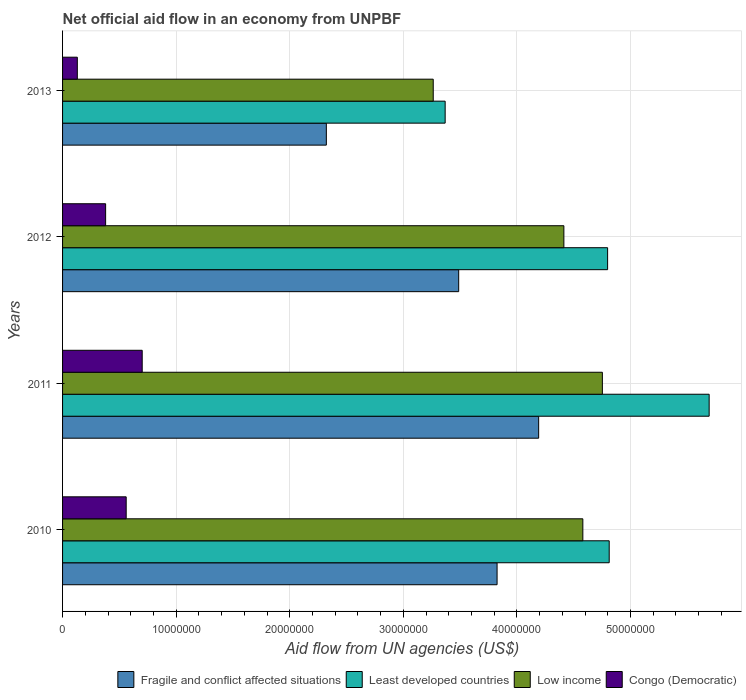How many different coloured bars are there?
Your answer should be compact. 4. How many groups of bars are there?
Give a very brief answer. 4. Are the number of bars per tick equal to the number of legend labels?
Offer a terse response. Yes. How many bars are there on the 1st tick from the top?
Make the answer very short. 4. What is the label of the 1st group of bars from the top?
Ensure brevity in your answer.  2013. In how many cases, is the number of bars for a given year not equal to the number of legend labels?
Your answer should be very brief. 0. What is the net official aid flow in Fragile and conflict affected situations in 2010?
Offer a terse response. 3.82e+07. Across all years, what is the maximum net official aid flow in Congo (Democratic)?
Give a very brief answer. 7.01e+06. Across all years, what is the minimum net official aid flow in Low income?
Give a very brief answer. 3.26e+07. In which year was the net official aid flow in Least developed countries maximum?
Keep it short and to the point. 2011. What is the total net official aid flow in Least developed countries in the graph?
Ensure brevity in your answer.  1.87e+08. What is the difference between the net official aid flow in Least developed countries in 2010 and that in 2013?
Your answer should be very brief. 1.44e+07. What is the difference between the net official aid flow in Least developed countries in 2011 and the net official aid flow in Low income in 2012?
Provide a succinct answer. 1.28e+07. What is the average net official aid flow in Low income per year?
Provide a short and direct response. 4.25e+07. In the year 2012, what is the difference between the net official aid flow in Fragile and conflict affected situations and net official aid flow in Congo (Democratic)?
Provide a succinct answer. 3.11e+07. What is the ratio of the net official aid flow in Congo (Democratic) in 2010 to that in 2013?
Your answer should be very brief. 4.31. Is the difference between the net official aid flow in Fragile and conflict affected situations in 2010 and 2011 greater than the difference between the net official aid flow in Congo (Democratic) in 2010 and 2011?
Your response must be concise. No. What is the difference between the highest and the second highest net official aid flow in Least developed countries?
Provide a succinct answer. 8.80e+06. What is the difference between the highest and the lowest net official aid flow in Least developed countries?
Offer a very short reply. 2.32e+07. In how many years, is the net official aid flow in Low income greater than the average net official aid flow in Low income taken over all years?
Your answer should be very brief. 3. Is the sum of the net official aid flow in Least developed countries in 2010 and 2011 greater than the maximum net official aid flow in Fragile and conflict affected situations across all years?
Your answer should be very brief. Yes. What does the 4th bar from the top in 2011 represents?
Provide a succinct answer. Fragile and conflict affected situations. What does the 1st bar from the bottom in 2011 represents?
Offer a terse response. Fragile and conflict affected situations. Are all the bars in the graph horizontal?
Give a very brief answer. Yes. How many years are there in the graph?
Your answer should be compact. 4. What is the difference between two consecutive major ticks on the X-axis?
Provide a succinct answer. 1.00e+07. Does the graph contain any zero values?
Ensure brevity in your answer.  No. Where does the legend appear in the graph?
Offer a very short reply. Bottom right. How many legend labels are there?
Give a very brief answer. 4. What is the title of the graph?
Offer a very short reply. Net official aid flow in an economy from UNPBF. Does "Ukraine" appear as one of the legend labels in the graph?
Ensure brevity in your answer.  No. What is the label or title of the X-axis?
Give a very brief answer. Aid flow from UN agencies (US$). What is the Aid flow from UN agencies (US$) in Fragile and conflict affected situations in 2010?
Offer a terse response. 3.82e+07. What is the Aid flow from UN agencies (US$) of Least developed countries in 2010?
Your answer should be very brief. 4.81e+07. What is the Aid flow from UN agencies (US$) in Low income in 2010?
Keep it short and to the point. 4.58e+07. What is the Aid flow from UN agencies (US$) in Congo (Democratic) in 2010?
Offer a very short reply. 5.60e+06. What is the Aid flow from UN agencies (US$) in Fragile and conflict affected situations in 2011?
Offer a terse response. 4.19e+07. What is the Aid flow from UN agencies (US$) in Least developed countries in 2011?
Ensure brevity in your answer.  5.69e+07. What is the Aid flow from UN agencies (US$) in Low income in 2011?
Provide a short and direct response. 4.75e+07. What is the Aid flow from UN agencies (US$) of Congo (Democratic) in 2011?
Offer a terse response. 7.01e+06. What is the Aid flow from UN agencies (US$) of Fragile and conflict affected situations in 2012?
Give a very brief answer. 3.49e+07. What is the Aid flow from UN agencies (US$) in Least developed countries in 2012?
Offer a terse response. 4.80e+07. What is the Aid flow from UN agencies (US$) in Low income in 2012?
Provide a short and direct response. 4.41e+07. What is the Aid flow from UN agencies (US$) of Congo (Democratic) in 2012?
Your answer should be compact. 3.79e+06. What is the Aid flow from UN agencies (US$) in Fragile and conflict affected situations in 2013?
Offer a terse response. 2.32e+07. What is the Aid flow from UN agencies (US$) of Least developed countries in 2013?
Your answer should be compact. 3.37e+07. What is the Aid flow from UN agencies (US$) of Low income in 2013?
Ensure brevity in your answer.  3.26e+07. What is the Aid flow from UN agencies (US$) in Congo (Democratic) in 2013?
Ensure brevity in your answer.  1.30e+06. Across all years, what is the maximum Aid flow from UN agencies (US$) of Fragile and conflict affected situations?
Give a very brief answer. 4.19e+07. Across all years, what is the maximum Aid flow from UN agencies (US$) in Least developed countries?
Provide a succinct answer. 5.69e+07. Across all years, what is the maximum Aid flow from UN agencies (US$) in Low income?
Keep it short and to the point. 4.75e+07. Across all years, what is the maximum Aid flow from UN agencies (US$) in Congo (Democratic)?
Offer a very short reply. 7.01e+06. Across all years, what is the minimum Aid flow from UN agencies (US$) of Fragile and conflict affected situations?
Your response must be concise. 2.32e+07. Across all years, what is the minimum Aid flow from UN agencies (US$) of Least developed countries?
Ensure brevity in your answer.  3.37e+07. Across all years, what is the minimum Aid flow from UN agencies (US$) in Low income?
Make the answer very short. 3.26e+07. Across all years, what is the minimum Aid flow from UN agencies (US$) in Congo (Democratic)?
Keep it short and to the point. 1.30e+06. What is the total Aid flow from UN agencies (US$) in Fragile and conflict affected situations in the graph?
Provide a short and direct response. 1.38e+08. What is the total Aid flow from UN agencies (US$) in Least developed countries in the graph?
Your answer should be very brief. 1.87e+08. What is the total Aid flow from UN agencies (US$) in Low income in the graph?
Your response must be concise. 1.70e+08. What is the total Aid flow from UN agencies (US$) in Congo (Democratic) in the graph?
Make the answer very short. 1.77e+07. What is the difference between the Aid flow from UN agencies (US$) in Fragile and conflict affected situations in 2010 and that in 2011?
Ensure brevity in your answer.  -3.66e+06. What is the difference between the Aid flow from UN agencies (US$) in Least developed countries in 2010 and that in 2011?
Offer a very short reply. -8.80e+06. What is the difference between the Aid flow from UN agencies (US$) in Low income in 2010 and that in 2011?
Provide a succinct answer. -1.72e+06. What is the difference between the Aid flow from UN agencies (US$) in Congo (Democratic) in 2010 and that in 2011?
Provide a succinct answer. -1.41e+06. What is the difference between the Aid flow from UN agencies (US$) of Fragile and conflict affected situations in 2010 and that in 2012?
Keep it short and to the point. 3.38e+06. What is the difference between the Aid flow from UN agencies (US$) of Low income in 2010 and that in 2012?
Your answer should be compact. 1.67e+06. What is the difference between the Aid flow from UN agencies (US$) of Congo (Democratic) in 2010 and that in 2012?
Offer a terse response. 1.81e+06. What is the difference between the Aid flow from UN agencies (US$) of Fragile and conflict affected situations in 2010 and that in 2013?
Provide a succinct answer. 1.50e+07. What is the difference between the Aid flow from UN agencies (US$) of Least developed countries in 2010 and that in 2013?
Your answer should be very brief. 1.44e+07. What is the difference between the Aid flow from UN agencies (US$) of Low income in 2010 and that in 2013?
Your answer should be compact. 1.32e+07. What is the difference between the Aid flow from UN agencies (US$) in Congo (Democratic) in 2010 and that in 2013?
Offer a terse response. 4.30e+06. What is the difference between the Aid flow from UN agencies (US$) in Fragile and conflict affected situations in 2011 and that in 2012?
Give a very brief answer. 7.04e+06. What is the difference between the Aid flow from UN agencies (US$) in Least developed countries in 2011 and that in 2012?
Provide a succinct answer. 8.94e+06. What is the difference between the Aid flow from UN agencies (US$) in Low income in 2011 and that in 2012?
Provide a succinct answer. 3.39e+06. What is the difference between the Aid flow from UN agencies (US$) of Congo (Democratic) in 2011 and that in 2012?
Ensure brevity in your answer.  3.22e+06. What is the difference between the Aid flow from UN agencies (US$) of Fragile and conflict affected situations in 2011 and that in 2013?
Offer a very short reply. 1.87e+07. What is the difference between the Aid flow from UN agencies (US$) of Least developed countries in 2011 and that in 2013?
Offer a terse response. 2.32e+07. What is the difference between the Aid flow from UN agencies (US$) in Low income in 2011 and that in 2013?
Your answer should be compact. 1.49e+07. What is the difference between the Aid flow from UN agencies (US$) in Congo (Democratic) in 2011 and that in 2013?
Provide a succinct answer. 5.71e+06. What is the difference between the Aid flow from UN agencies (US$) of Fragile and conflict affected situations in 2012 and that in 2013?
Make the answer very short. 1.16e+07. What is the difference between the Aid flow from UN agencies (US$) in Least developed countries in 2012 and that in 2013?
Your answer should be very brief. 1.43e+07. What is the difference between the Aid flow from UN agencies (US$) of Low income in 2012 and that in 2013?
Your answer should be very brief. 1.15e+07. What is the difference between the Aid flow from UN agencies (US$) in Congo (Democratic) in 2012 and that in 2013?
Offer a very short reply. 2.49e+06. What is the difference between the Aid flow from UN agencies (US$) of Fragile and conflict affected situations in 2010 and the Aid flow from UN agencies (US$) of Least developed countries in 2011?
Offer a terse response. -1.87e+07. What is the difference between the Aid flow from UN agencies (US$) in Fragile and conflict affected situations in 2010 and the Aid flow from UN agencies (US$) in Low income in 2011?
Your answer should be very brief. -9.27e+06. What is the difference between the Aid flow from UN agencies (US$) in Fragile and conflict affected situations in 2010 and the Aid flow from UN agencies (US$) in Congo (Democratic) in 2011?
Your answer should be compact. 3.12e+07. What is the difference between the Aid flow from UN agencies (US$) of Least developed countries in 2010 and the Aid flow from UN agencies (US$) of Low income in 2011?
Provide a succinct answer. 6.00e+05. What is the difference between the Aid flow from UN agencies (US$) of Least developed countries in 2010 and the Aid flow from UN agencies (US$) of Congo (Democratic) in 2011?
Offer a very short reply. 4.11e+07. What is the difference between the Aid flow from UN agencies (US$) of Low income in 2010 and the Aid flow from UN agencies (US$) of Congo (Democratic) in 2011?
Provide a succinct answer. 3.88e+07. What is the difference between the Aid flow from UN agencies (US$) of Fragile and conflict affected situations in 2010 and the Aid flow from UN agencies (US$) of Least developed countries in 2012?
Provide a succinct answer. -9.73e+06. What is the difference between the Aid flow from UN agencies (US$) of Fragile and conflict affected situations in 2010 and the Aid flow from UN agencies (US$) of Low income in 2012?
Make the answer very short. -5.88e+06. What is the difference between the Aid flow from UN agencies (US$) of Fragile and conflict affected situations in 2010 and the Aid flow from UN agencies (US$) of Congo (Democratic) in 2012?
Give a very brief answer. 3.45e+07. What is the difference between the Aid flow from UN agencies (US$) of Least developed countries in 2010 and the Aid flow from UN agencies (US$) of Low income in 2012?
Your answer should be compact. 3.99e+06. What is the difference between the Aid flow from UN agencies (US$) of Least developed countries in 2010 and the Aid flow from UN agencies (US$) of Congo (Democratic) in 2012?
Your answer should be very brief. 4.43e+07. What is the difference between the Aid flow from UN agencies (US$) in Low income in 2010 and the Aid flow from UN agencies (US$) in Congo (Democratic) in 2012?
Your response must be concise. 4.20e+07. What is the difference between the Aid flow from UN agencies (US$) in Fragile and conflict affected situations in 2010 and the Aid flow from UN agencies (US$) in Least developed countries in 2013?
Your answer should be very brief. 4.57e+06. What is the difference between the Aid flow from UN agencies (US$) in Fragile and conflict affected situations in 2010 and the Aid flow from UN agencies (US$) in Low income in 2013?
Make the answer very short. 5.62e+06. What is the difference between the Aid flow from UN agencies (US$) in Fragile and conflict affected situations in 2010 and the Aid flow from UN agencies (US$) in Congo (Democratic) in 2013?
Offer a terse response. 3.70e+07. What is the difference between the Aid flow from UN agencies (US$) of Least developed countries in 2010 and the Aid flow from UN agencies (US$) of Low income in 2013?
Offer a very short reply. 1.55e+07. What is the difference between the Aid flow from UN agencies (US$) of Least developed countries in 2010 and the Aid flow from UN agencies (US$) of Congo (Democratic) in 2013?
Provide a short and direct response. 4.68e+07. What is the difference between the Aid flow from UN agencies (US$) in Low income in 2010 and the Aid flow from UN agencies (US$) in Congo (Democratic) in 2013?
Keep it short and to the point. 4.45e+07. What is the difference between the Aid flow from UN agencies (US$) of Fragile and conflict affected situations in 2011 and the Aid flow from UN agencies (US$) of Least developed countries in 2012?
Offer a very short reply. -6.07e+06. What is the difference between the Aid flow from UN agencies (US$) in Fragile and conflict affected situations in 2011 and the Aid flow from UN agencies (US$) in Low income in 2012?
Give a very brief answer. -2.22e+06. What is the difference between the Aid flow from UN agencies (US$) of Fragile and conflict affected situations in 2011 and the Aid flow from UN agencies (US$) of Congo (Democratic) in 2012?
Keep it short and to the point. 3.81e+07. What is the difference between the Aid flow from UN agencies (US$) of Least developed countries in 2011 and the Aid flow from UN agencies (US$) of Low income in 2012?
Your response must be concise. 1.28e+07. What is the difference between the Aid flow from UN agencies (US$) of Least developed countries in 2011 and the Aid flow from UN agencies (US$) of Congo (Democratic) in 2012?
Keep it short and to the point. 5.31e+07. What is the difference between the Aid flow from UN agencies (US$) in Low income in 2011 and the Aid flow from UN agencies (US$) in Congo (Democratic) in 2012?
Give a very brief answer. 4.37e+07. What is the difference between the Aid flow from UN agencies (US$) in Fragile and conflict affected situations in 2011 and the Aid flow from UN agencies (US$) in Least developed countries in 2013?
Ensure brevity in your answer.  8.23e+06. What is the difference between the Aid flow from UN agencies (US$) of Fragile and conflict affected situations in 2011 and the Aid flow from UN agencies (US$) of Low income in 2013?
Your answer should be compact. 9.28e+06. What is the difference between the Aid flow from UN agencies (US$) in Fragile and conflict affected situations in 2011 and the Aid flow from UN agencies (US$) in Congo (Democratic) in 2013?
Your answer should be very brief. 4.06e+07. What is the difference between the Aid flow from UN agencies (US$) of Least developed countries in 2011 and the Aid flow from UN agencies (US$) of Low income in 2013?
Provide a succinct answer. 2.43e+07. What is the difference between the Aid flow from UN agencies (US$) of Least developed countries in 2011 and the Aid flow from UN agencies (US$) of Congo (Democratic) in 2013?
Keep it short and to the point. 5.56e+07. What is the difference between the Aid flow from UN agencies (US$) of Low income in 2011 and the Aid flow from UN agencies (US$) of Congo (Democratic) in 2013?
Give a very brief answer. 4.62e+07. What is the difference between the Aid flow from UN agencies (US$) of Fragile and conflict affected situations in 2012 and the Aid flow from UN agencies (US$) of Least developed countries in 2013?
Your answer should be compact. 1.19e+06. What is the difference between the Aid flow from UN agencies (US$) in Fragile and conflict affected situations in 2012 and the Aid flow from UN agencies (US$) in Low income in 2013?
Your answer should be compact. 2.24e+06. What is the difference between the Aid flow from UN agencies (US$) of Fragile and conflict affected situations in 2012 and the Aid flow from UN agencies (US$) of Congo (Democratic) in 2013?
Give a very brief answer. 3.36e+07. What is the difference between the Aid flow from UN agencies (US$) in Least developed countries in 2012 and the Aid flow from UN agencies (US$) in Low income in 2013?
Offer a very short reply. 1.54e+07. What is the difference between the Aid flow from UN agencies (US$) of Least developed countries in 2012 and the Aid flow from UN agencies (US$) of Congo (Democratic) in 2013?
Provide a succinct answer. 4.67e+07. What is the difference between the Aid flow from UN agencies (US$) of Low income in 2012 and the Aid flow from UN agencies (US$) of Congo (Democratic) in 2013?
Give a very brief answer. 4.28e+07. What is the average Aid flow from UN agencies (US$) in Fragile and conflict affected situations per year?
Your response must be concise. 3.46e+07. What is the average Aid flow from UN agencies (US$) of Least developed countries per year?
Keep it short and to the point. 4.67e+07. What is the average Aid flow from UN agencies (US$) of Low income per year?
Ensure brevity in your answer.  4.25e+07. What is the average Aid flow from UN agencies (US$) in Congo (Democratic) per year?
Ensure brevity in your answer.  4.42e+06. In the year 2010, what is the difference between the Aid flow from UN agencies (US$) of Fragile and conflict affected situations and Aid flow from UN agencies (US$) of Least developed countries?
Give a very brief answer. -9.87e+06. In the year 2010, what is the difference between the Aid flow from UN agencies (US$) in Fragile and conflict affected situations and Aid flow from UN agencies (US$) in Low income?
Offer a terse response. -7.55e+06. In the year 2010, what is the difference between the Aid flow from UN agencies (US$) of Fragile and conflict affected situations and Aid flow from UN agencies (US$) of Congo (Democratic)?
Offer a very short reply. 3.26e+07. In the year 2010, what is the difference between the Aid flow from UN agencies (US$) in Least developed countries and Aid flow from UN agencies (US$) in Low income?
Offer a terse response. 2.32e+06. In the year 2010, what is the difference between the Aid flow from UN agencies (US$) of Least developed countries and Aid flow from UN agencies (US$) of Congo (Democratic)?
Ensure brevity in your answer.  4.25e+07. In the year 2010, what is the difference between the Aid flow from UN agencies (US$) of Low income and Aid flow from UN agencies (US$) of Congo (Democratic)?
Provide a succinct answer. 4.02e+07. In the year 2011, what is the difference between the Aid flow from UN agencies (US$) in Fragile and conflict affected situations and Aid flow from UN agencies (US$) in Least developed countries?
Your response must be concise. -1.50e+07. In the year 2011, what is the difference between the Aid flow from UN agencies (US$) in Fragile and conflict affected situations and Aid flow from UN agencies (US$) in Low income?
Offer a very short reply. -5.61e+06. In the year 2011, what is the difference between the Aid flow from UN agencies (US$) in Fragile and conflict affected situations and Aid flow from UN agencies (US$) in Congo (Democratic)?
Your answer should be very brief. 3.49e+07. In the year 2011, what is the difference between the Aid flow from UN agencies (US$) in Least developed countries and Aid flow from UN agencies (US$) in Low income?
Make the answer very short. 9.40e+06. In the year 2011, what is the difference between the Aid flow from UN agencies (US$) in Least developed countries and Aid flow from UN agencies (US$) in Congo (Democratic)?
Your answer should be compact. 4.99e+07. In the year 2011, what is the difference between the Aid flow from UN agencies (US$) in Low income and Aid flow from UN agencies (US$) in Congo (Democratic)?
Offer a terse response. 4.05e+07. In the year 2012, what is the difference between the Aid flow from UN agencies (US$) in Fragile and conflict affected situations and Aid flow from UN agencies (US$) in Least developed countries?
Keep it short and to the point. -1.31e+07. In the year 2012, what is the difference between the Aid flow from UN agencies (US$) of Fragile and conflict affected situations and Aid flow from UN agencies (US$) of Low income?
Your response must be concise. -9.26e+06. In the year 2012, what is the difference between the Aid flow from UN agencies (US$) of Fragile and conflict affected situations and Aid flow from UN agencies (US$) of Congo (Democratic)?
Your response must be concise. 3.11e+07. In the year 2012, what is the difference between the Aid flow from UN agencies (US$) in Least developed countries and Aid flow from UN agencies (US$) in Low income?
Your answer should be very brief. 3.85e+06. In the year 2012, what is the difference between the Aid flow from UN agencies (US$) in Least developed countries and Aid flow from UN agencies (US$) in Congo (Democratic)?
Provide a succinct answer. 4.42e+07. In the year 2012, what is the difference between the Aid flow from UN agencies (US$) of Low income and Aid flow from UN agencies (US$) of Congo (Democratic)?
Make the answer very short. 4.03e+07. In the year 2013, what is the difference between the Aid flow from UN agencies (US$) of Fragile and conflict affected situations and Aid flow from UN agencies (US$) of Least developed countries?
Offer a very short reply. -1.05e+07. In the year 2013, what is the difference between the Aid flow from UN agencies (US$) in Fragile and conflict affected situations and Aid flow from UN agencies (US$) in Low income?
Keep it short and to the point. -9.41e+06. In the year 2013, what is the difference between the Aid flow from UN agencies (US$) in Fragile and conflict affected situations and Aid flow from UN agencies (US$) in Congo (Democratic)?
Provide a short and direct response. 2.19e+07. In the year 2013, what is the difference between the Aid flow from UN agencies (US$) of Least developed countries and Aid flow from UN agencies (US$) of Low income?
Keep it short and to the point. 1.05e+06. In the year 2013, what is the difference between the Aid flow from UN agencies (US$) in Least developed countries and Aid flow from UN agencies (US$) in Congo (Democratic)?
Provide a short and direct response. 3.24e+07. In the year 2013, what is the difference between the Aid flow from UN agencies (US$) in Low income and Aid flow from UN agencies (US$) in Congo (Democratic)?
Provide a short and direct response. 3.13e+07. What is the ratio of the Aid flow from UN agencies (US$) in Fragile and conflict affected situations in 2010 to that in 2011?
Make the answer very short. 0.91. What is the ratio of the Aid flow from UN agencies (US$) of Least developed countries in 2010 to that in 2011?
Provide a short and direct response. 0.85. What is the ratio of the Aid flow from UN agencies (US$) in Low income in 2010 to that in 2011?
Your response must be concise. 0.96. What is the ratio of the Aid flow from UN agencies (US$) of Congo (Democratic) in 2010 to that in 2011?
Ensure brevity in your answer.  0.8. What is the ratio of the Aid flow from UN agencies (US$) in Fragile and conflict affected situations in 2010 to that in 2012?
Keep it short and to the point. 1.1. What is the ratio of the Aid flow from UN agencies (US$) in Low income in 2010 to that in 2012?
Make the answer very short. 1.04. What is the ratio of the Aid flow from UN agencies (US$) of Congo (Democratic) in 2010 to that in 2012?
Your response must be concise. 1.48. What is the ratio of the Aid flow from UN agencies (US$) in Fragile and conflict affected situations in 2010 to that in 2013?
Your answer should be very brief. 1.65. What is the ratio of the Aid flow from UN agencies (US$) of Least developed countries in 2010 to that in 2013?
Keep it short and to the point. 1.43. What is the ratio of the Aid flow from UN agencies (US$) in Low income in 2010 to that in 2013?
Keep it short and to the point. 1.4. What is the ratio of the Aid flow from UN agencies (US$) in Congo (Democratic) in 2010 to that in 2013?
Make the answer very short. 4.31. What is the ratio of the Aid flow from UN agencies (US$) in Fragile and conflict affected situations in 2011 to that in 2012?
Provide a short and direct response. 1.2. What is the ratio of the Aid flow from UN agencies (US$) of Least developed countries in 2011 to that in 2012?
Ensure brevity in your answer.  1.19. What is the ratio of the Aid flow from UN agencies (US$) of Low income in 2011 to that in 2012?
Your response must be concise. 1.08. What is the ratio of the Aid flow from UN agencies (US$) of Congo (Democratic) in 2011 to that in 2012?
Provide a short and direct response. 1.85. What is the ratio of the Aid flow from UN agencies (US$) of Fragile and conflict affected situations in 2011 to that in 2013?
Your response must be concise. 1.8. What is the ratio of the Aid flow from UN agencies (US$) of Least developed countries in 2011 to that in 2013?
Make the answer very short. 1.69. What is the ratio of the Aid flow from UN agencies (US$) of Low income in 2011 to that in 2013?
Provide a succinct answer. 1.46. What is the ratio of the Aid flow from UN agencies (US$) of Congo (Democratic) in 2011 to that in 2013?
Give a very brief answer. 5.39. What is the ratio of the Aid flow from UN agencies (US$) in Fragile and conflict affected situations in 2012 to that in 2013?
Offer a terse response. 1.5. What is the ratio of the Aid flow from UN agencies (US$) in Least developed countries in 2012 to that in 2013?
Provide a succinct answer. 1.42. What is the ratio of the Aid flow from UN agencies (US$) of Low income in 2012 to that in 2013?
Keep it short and to the point. 1.35. What is the ratio of the Aid flow from UN agencies (US$) of Congo (Democratic) in 2012 to that in 2013?
Give a very brief answer. 2.92. What is the difference between the highest and the second highest Aid flow from UN agencies (US$) of Fragile and conflict affected situations?
Make the answer very short. 3.66e+06. What is the difference between the highest and the second highest Aid flow from UN agencies (US$) of Least developed countries?
Offer a terse response. 8.80e+06. What is the difference between the highest and the second highest Aid flow from UN agencies (US$) in Low income?
Your answer should be compact. 1.72e+06. What is the difference between the highest and the second highest Aid flow from UN agencies (US$) of Congo (Democratic)?
Provide a succinct answer. 1.41e+06. What is the difference between the highest and the lowest Aid flow from UN agencies (US$) of Fragile and conflict affected situations?
Your answer should be compact. 1.87e+07. What is the difference between the highest and the lowest Aid flow from UN agencies (US$) in Least developed countries?
Keep it short and to the point. 2.32e+07. What is the difference between the highest and the lowest Aid flow from UN agencies (US$) in Low income?
Offer a very short reply. 1.49e+07. What is the difference between the highest and the lowest Aid flow from UN agencies (US$) of Congo (Democratic)?
Offer a very short reply. 5.71e+06. 